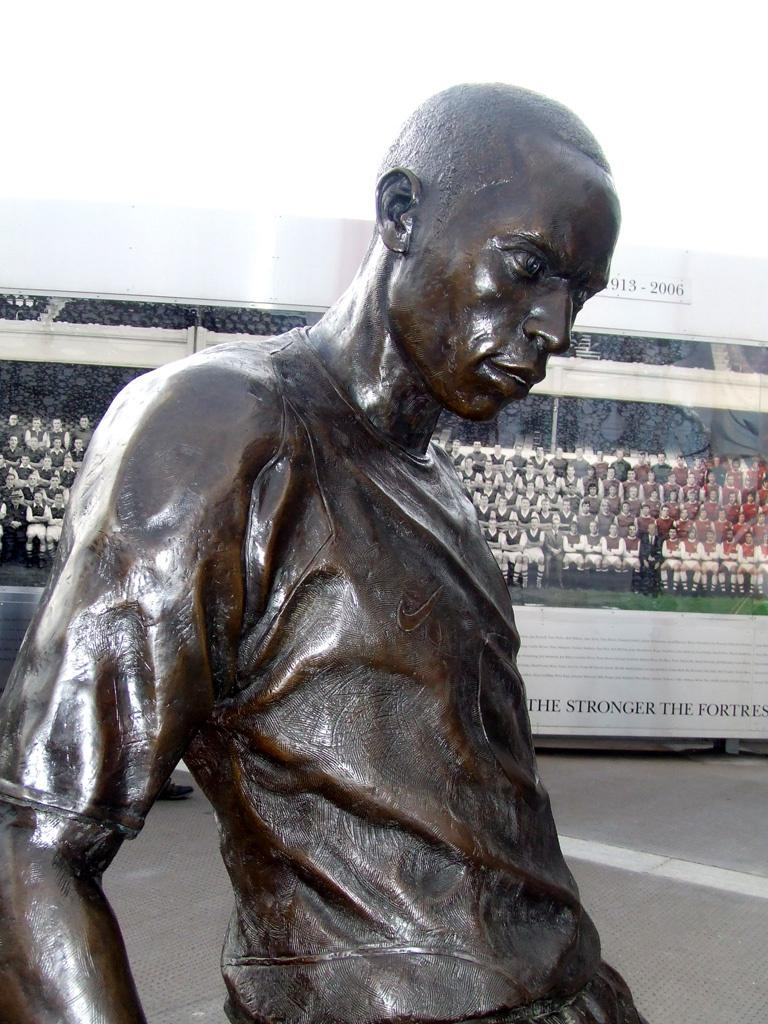What is the main subject in the image? There is a statue of a person in the image. What can be seen in the background of the image? There is a banner in the background of the image. What is written or depicted on the banner? The banner has text on it and an image of a group of people. Where is the shelf located in the image? There is no shelf present in the image. What type of lock is used on the house in the image? There is no house or lock present in the image. 